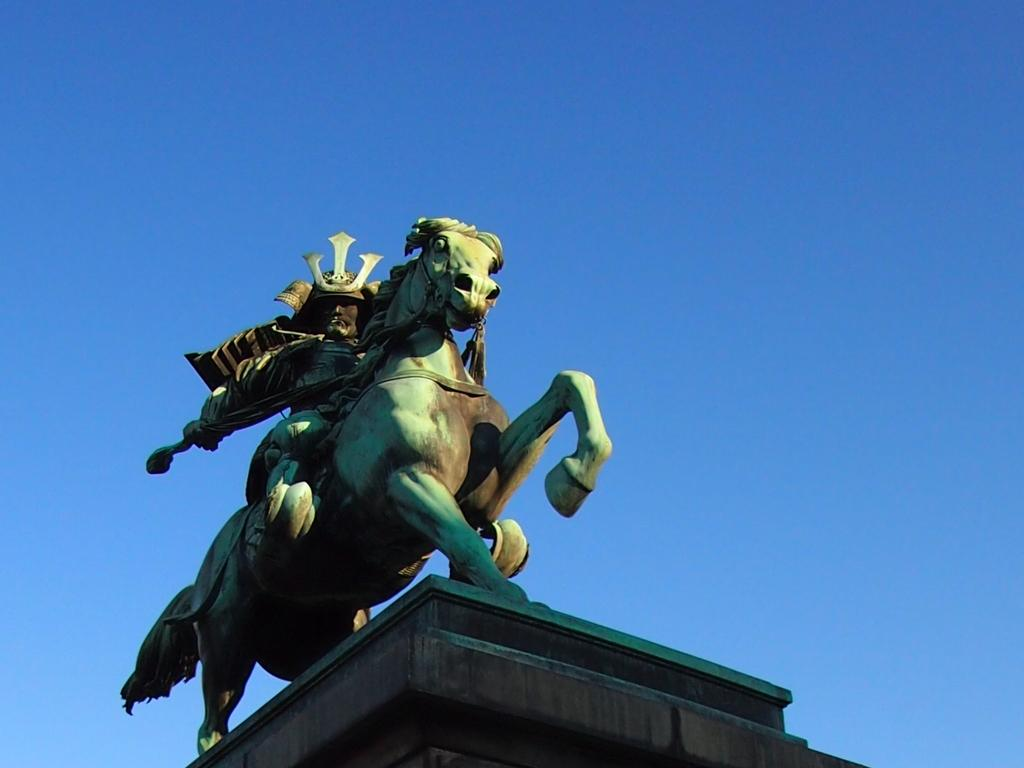What is the main subject of the image? There is a sculpture of a horse in the image. What is the man in the image doing? A man is sitting on the horse sculpture. What can be seen in the background of the image? The sky is visible in the background of the image. Can you hear the ghost talking to the man in the image? There is no ghost present in the image, and therefore no conversation can be heard. What type of lettuce is growing near the horse sculpture in the image? There is no lettuce present in the image; it features a horse sculpture and a man sitting on it. 